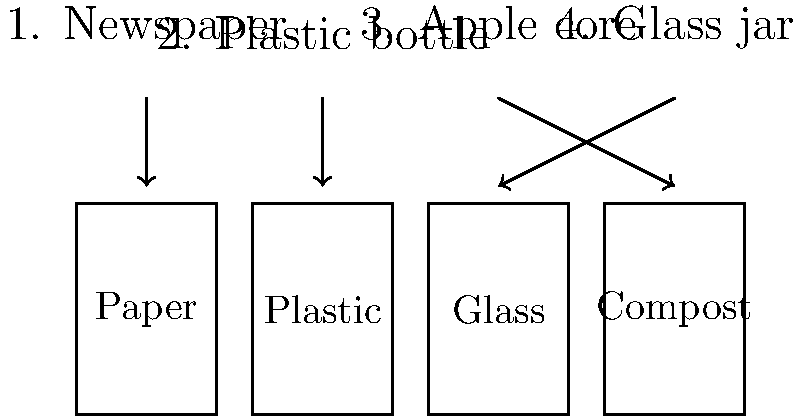Based on the image, which item is incorrectly sorted into its recycling bin? Let's analyze each item and its corresponding bin:

1. Newspaper → Paper bin: This is correct. Newspapers are made of paper and belong in the paper recycling bin.

2. Plastic bottle → Plastic bin: This is correct. Plastic bottles should be recycled in the plastic bin.

3. Apple core → Glass bin: This is incorrect. Apple cores are organic waste and should be composted.

4. Glass jar → Compost bin: This is incorrect. Glass jars should be recycled in the glass bin, not composted.

Comparing the two incorrect placements:
- The apple core (item 3) is shown going into the glass bin, which is clearly wrong.
- The glass jar (item 4) is shown going into the compost bin, which is also clearly wrong.

However, the question asks for the item that is incorrectly sorted, not the bin that has an incorrect item. Therefore, we need to identify which item is in the wrong place.

The apple core (item 3) is the one that is incorrectly sorted, as it's shown going into the glass bin instead of the compost bin.
Answer: Apple core 